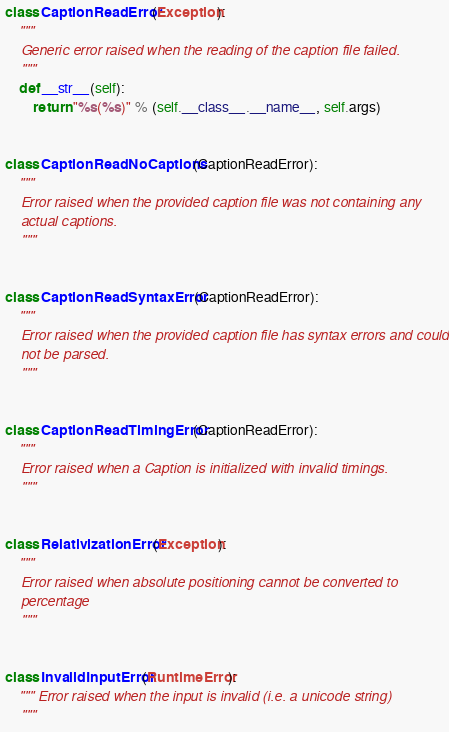Convert code to text. <code><loc_0><loc_0><loc_500><loc_500><_Python_>

class CaptionReadError(Exception):
    """
    Generic error raised when the reading of the caption file failed.
    """
    def __str__(self):
        return "%s(%s)" % (self.__class__.__name__, self.args)


class CaptionReadNoCaptions(CaptionReadError):
    """
    Error raised when the provided caption file was not containing any
    actual captions.
    """


class CaptionReadSyntaxError(CaptionReadError):
    """
    Error raised when the provided caption file has syntax errors and could
    not be parsed.
    """


class CaptionReadTimingError(CaptionReadError):
    """
    Error raised when a Caption is initialized with invalid timings.
    """


class RelativizationError(Exception):
    """
    Error raised when absolute positioning cannot be converted to
    percentage
    """


class InvalidInputError(RuntimeError):
    """ Error raised when the input is invalid (i.e. a unicode string)
    """

</code> 